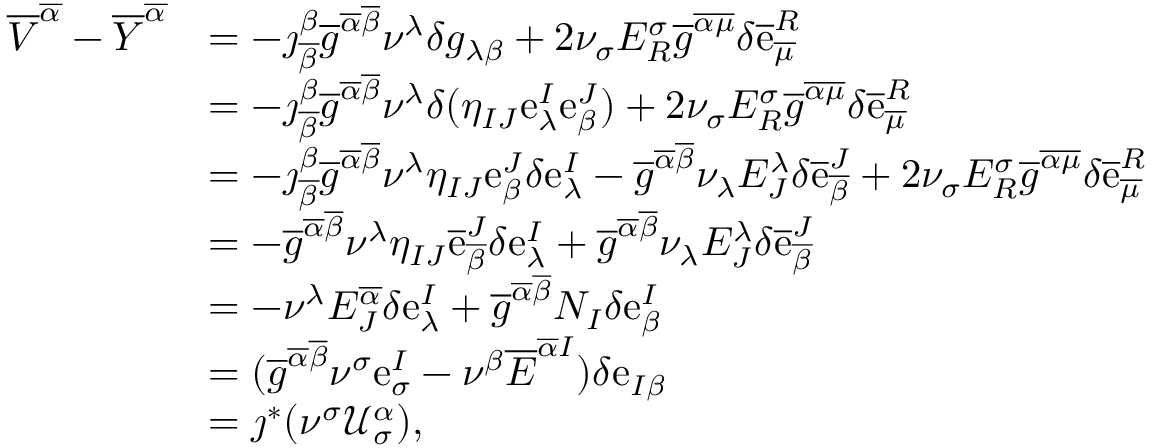<formula> <loc_0><loc_0><loc_500><loc_500>\begin{array} { r l } { \overline { V } ^ { \overline { \alpha } } - \overline { Y } ^ { \overline { \alpha } } } & { = - \jmath _ { \overline { \beta } } ^ { \beta } \overline { g } ^ { \overline { \alpha } \overline { \beta } } \nu ^ { \lambda } \delta g _ { \lambda \beta } + 2 \nu _ { \sigma } E _ { R } ^ { \sigma } \overline { g } ^ { \overline { \alpha } \overline { \mu } } \delta \overline { e } _ { \overline { \mu } } ^ { R } } \\ & { = - \jmath _ { \overline { \beta } } ^ { \beta } \overline { g } ^ { \overline { \alpha } \overline { \beta } } \nu ^ { \lambda } \delta ( \eta _ { I J } e _ { \lambda } ^ { I } e _ { \beta } ^ { J } ) + 2 \nu _ { \sigma } E _ { R } ^ { \sigma } \overline { g } ^ { \overline { \alpha } \overline { \mu } } \delta \overline { e } _ { \overline { \mu } } ^ { R } } \\ & { = - \jmath _ { \overline { \beta } } ^ { \beta } \overline { g } ^ { \overline { \alpha } \overline { \beta } } \nu ^ { \lambda } \eta _ { I J } e _ { \beta } ^ { J } \delta e _ { \lambda } ^ { I } - \overline { g } ^ { \overline { \alpha } \overline { \beta } } \nu _ { \lambda } E _ { J } ^ { \lambda } \delta \overline { e } _ { \overline { \beta } } ^ { J } + 2 \nu _ { \sigma } E _ { R } ^ { \sigma } \overline { g } ^ { \overline { \alpha } \overline { \mu } } \delta \overline { e } _ { \overline { \mu } } ^ { R } } \\ & { = - \overline { g } ^ { \overline { \alpha } \overline { \beta } } \nu ^ { \lambda } \eta _ { I J } \overline { e } _ { \overline { \beta } } ^ { J } \delta e _ { \lambda } ^ { I } + \overline { g } ^ { \overline { \alpha } \overline { \beta } } \nu _ { \lambda } E _ { J } ^ { \lambda } \delta \overline { e } _ { \overline { \beta } } ^ { J } } \\ & { = - \nu ^ { \lambda } E _ { J } ^ { \overline { \alpha } } \delta e _ { \lambda } ^ { I } + \overline { g } ^ { \overline { \alpha } \overline { \beta } } N _ { I } \delta e _ { \beta } ^ { I } } \\ & { = ( \overline { g } ^ { \overline { \alpha } \overline { \beta } } \nu ^ { \sigma } e _ { \sigma } ^ { I } - \nu ^ { \beta } \overline { E } ^ { \overline { \alpha } I } ) \delta e _ { I \beta } } \\ & { = \jmath ^ { * } ( \nu ^ { \sigma } \mathcal { U } _ { \sigma } ^ { \alpha } ) , } \end{array}</formula> 